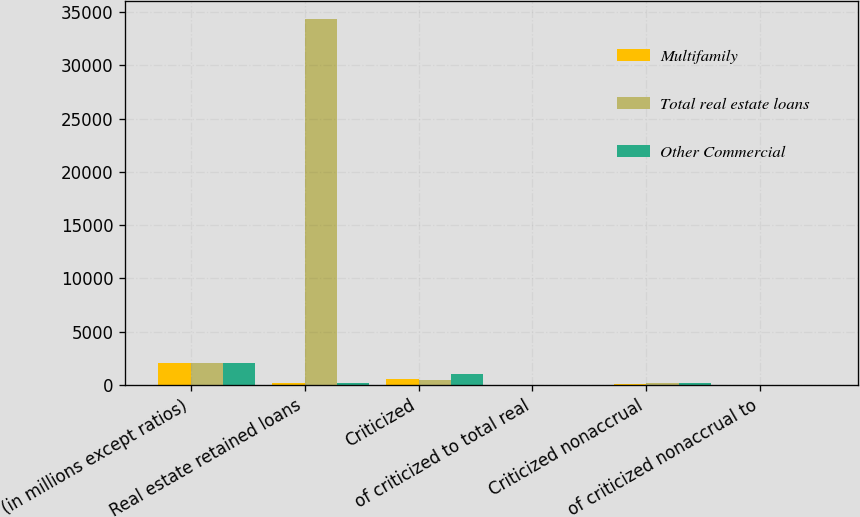Convert chart. <chart><loc_0><loc_0><loc_500><loc_500><stacked_bar_chart><ecel><fcel>(in millions except ratios)<fcel>Real estate retained loans<fcel>Criticized<fcel>of criticized to total real<fcel>Criticized nonaccrual<fcel>of criticized nonaccrual to<nl><fcel>Multifamily<fcel>2016<fcel>171.5<fcel>539<fcel>0.75<fcel>57<fcel>0.08<nl><fcel>Total real estate loans<fcel>2016<fcel>34337<fcel>459<fcel>1.34<fcel>143<fcel>0.42<nl><fcel>Other Commercial<fcel>2016<fcel>171.5<fcel>998<fcel>0.94<fcel>200<fcel>0.19<nl></chart> 